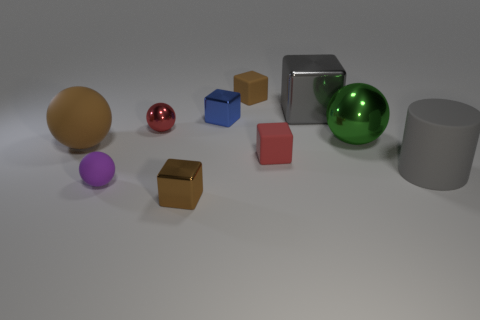If these objects were used in a physics demonstration, what topics could be covered? These objects could be used to demonstrate topics such as material density, the principles of reflection and refraction, the basics of collision and transfer of momentum, and the concepts of balance and center of mass. 